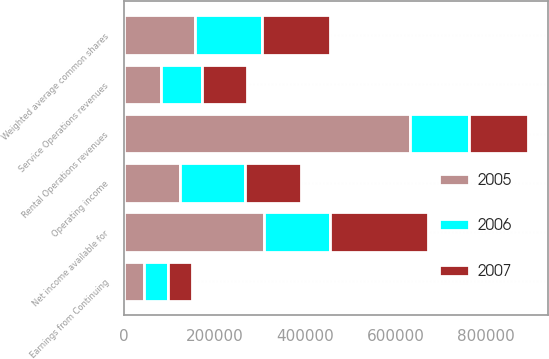<chart> <loc_0><loc_0><loc_500><loc_500><stacked_bar_chart><ecel><fcel>Rental Operations revenues<fcel>Service Operations revenues<fcel>Earnings from Continuing<fcel>Operating income<fcel>Net income available for<fcel>Weighted average common shares<nl><fcel>2007<fcel>130198<fcel>99358<fcel>52034<fcel>123433<fcel>217692<fcel>149614<nl><fcel>2006<fcel>130198<fcel>90125<fcel>53196<fcel>142913<fcel>145095<fcel>149393<nl><fcel>2005<fcel>631611<fcel>81941<fcel>44278<fcel>124128<fcel>309183<fcel>155877<nl></chart> 